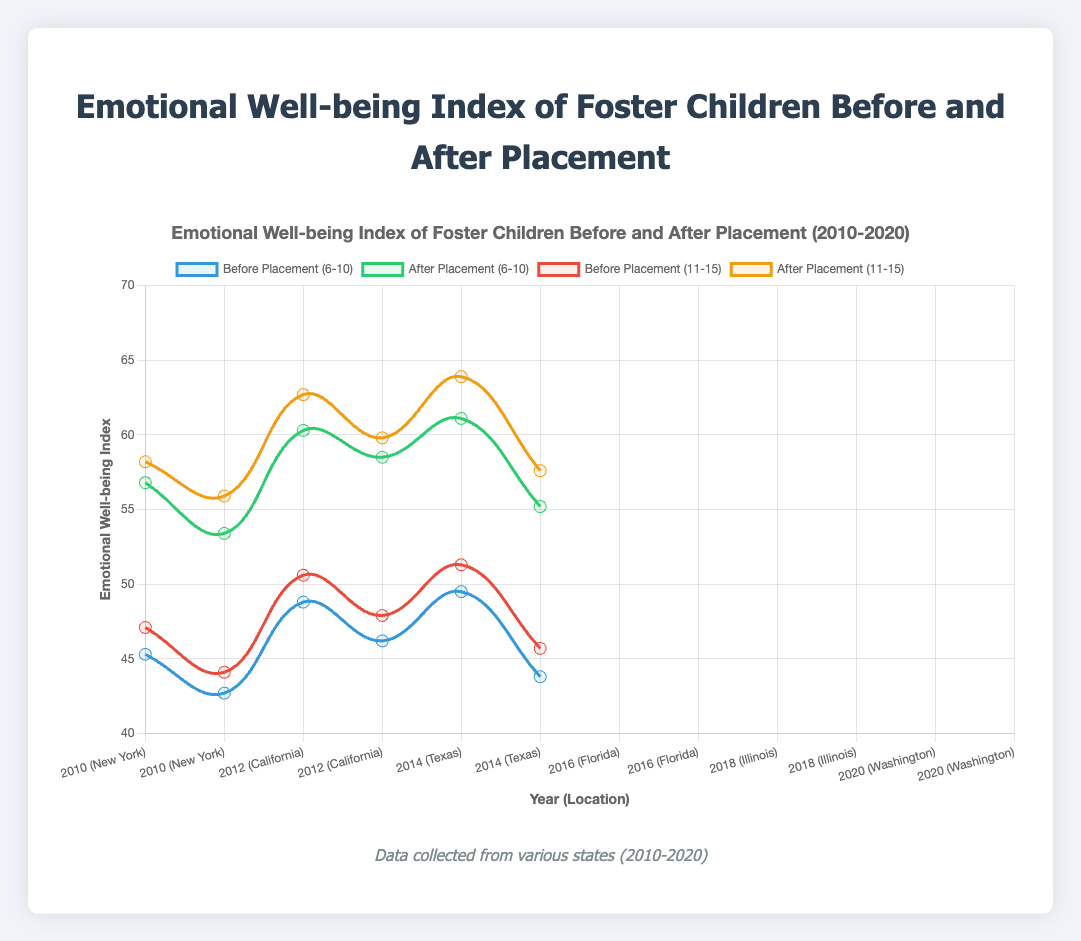What is the difference in the emotional well-being index after placement for the age group 6-10 between the years 2010 and 2020? In 2010, the emotional well-being index after placement for the age group 6-10 is 56.8, and in 2020, it is 55.2. The difference is calculated as 56.8 - 55.2.
Answer: 1.6 Which year and location had the highest emotional well-being index before placement for the age group 11-15? To find this, we check the values for 'before placement' for the age group 11-15 across all years and locations. The highest value is 51.3 for Illinois in 2018.
Answer: 2018, Illinois Between children aged 6-10 and 11-15, which age group showed a greater improvement in the emotional well-being index after placement in 2012? In 2012, the improvement for the age group 6-10 is 53.4 - 42.7 = 10.7. For the age group 11-15, it is 55.9 - 44.1 = 11.8. Hence, the age group 11-15 shows a greater improvement.
Answer: 11-15 What is the average emotional well-being index before placement for children aged 6-10 across all years? The values before placement for children aged 6-10 are 45.3, 42.7, 48.8, 46.2, 49.5, and 43.8. The sum is (45.3 + 42.7 + 48.8 + 46.2 + 49.5 + 43.8) = 276.3. There are 6 data points, so the average is 276.3 / 6.
Answer: 46.05 Which color represents the emotional well-being index after placement for children aged 6-10 in the chart? In the chart, the color representing the emotional well-being index after placement for children aged 6-10 is green.
Answer: Green In what year did children aged 6-10 in Texas have an emotional well-being index before placement of 48.8? By checking the data, children aged 6-10 in Texas had an emotional well-being index before placement of 48.8 in the year 2014.
Answer: 2014 What is the trend of the emotional well-being index after placement for children aged 11-15 from 2010 to 2020? From the data, in 2010 (58.2), 2012 (55.9), 2014 (62.7), 2016 (59.8), 2018 (63.9), and 2020 (57.6), there is an increase followed by a slight dip around the year 2020. The general trend shows an overall increase over the years.
Answer: Increasing trend with fluctuation Compare the improvement in emotional well-being index for children aged 11-15 between Florida and New York in their respective years of data collection? For New York in 2010, the improvement is 58.2 - 47.1 = 11.1. For Florida in 2016, the improvement is 59.8 - 47.9 = 11.9. Florida shows a greater improvement compared to New York.
Answer: Florida 